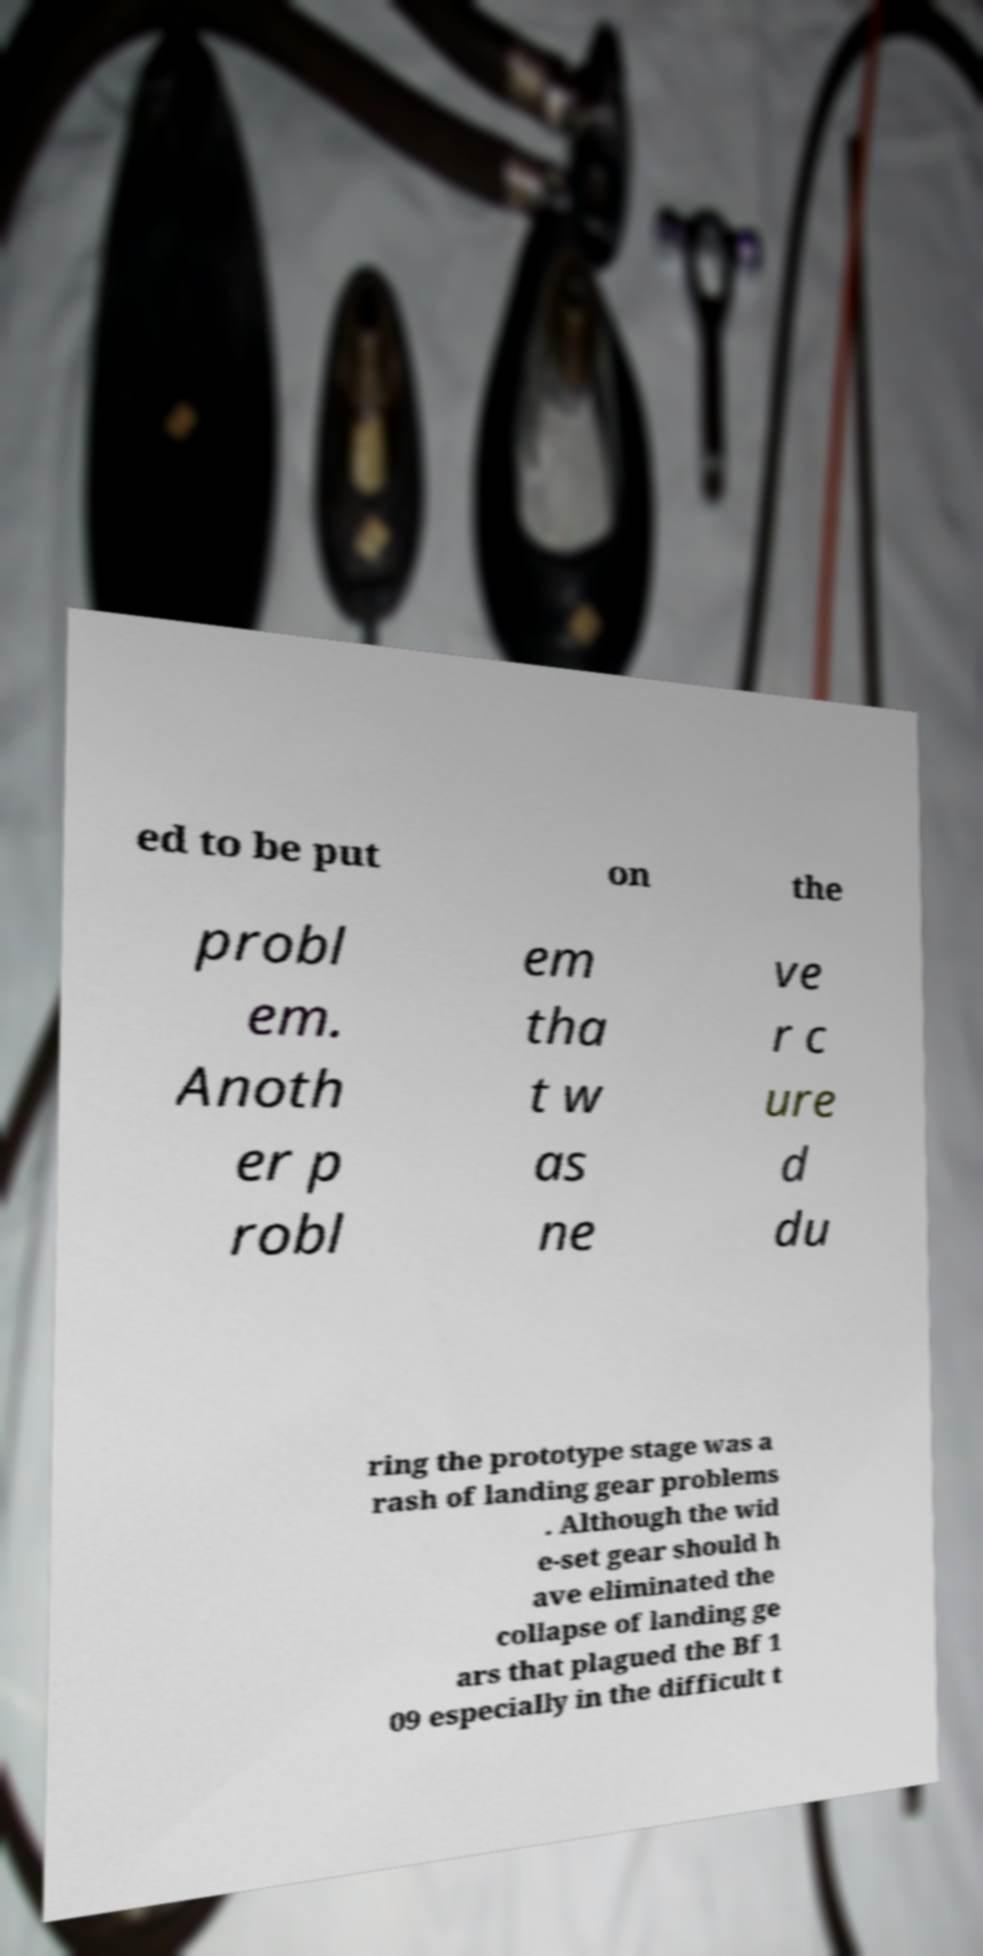Please read and relay the text visible in this image. What does it say? ed to be put on the probl em. Anoth er p robl em tha t w as ne ve r c ure d du ring the prototype stage was a rash of landing gear problems . Although the wid e-set gear should h ave eliminated the collapse of landing ge ars that plagued the Bf 1 09 especially in the difficult t 